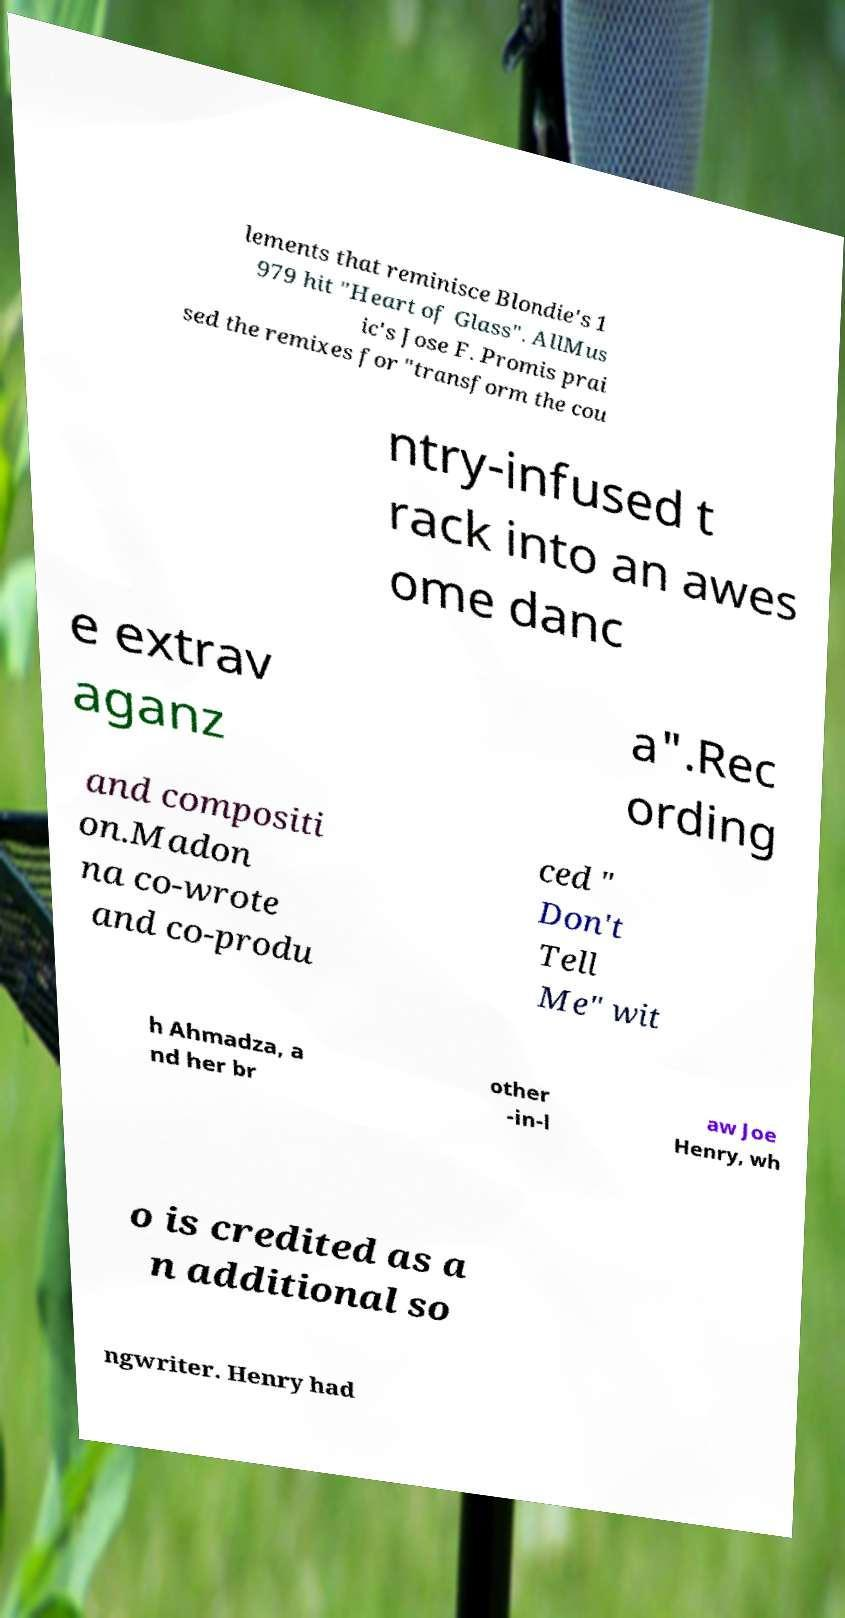I need the written content from this picture converted into text. Can you do that? lements that reminisce Blondie's 1 979 hit "Heart of Glass". AllMus ic's Jose F. Promis prai sed the remixes for "transform the cou ntry-infused t rack into an awes ome danc e extrav aganz a".Rec ording and compositi on.Madon na co-wrote and co-produ ced " Don't Tell Me" wit h Ahmadza, a nd her br other -in-l aw Joe Henry, wh o is credited as a n additional so ngwriter. Henry had 